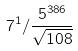Convert formula to latex. <formula><loc_0><loc_0><loc_500><loc_500>7 ^ { 1 } / \frac { 5 ^ { 3 8 6 } } { \sqrt { 1 0 8 } }</formula> 